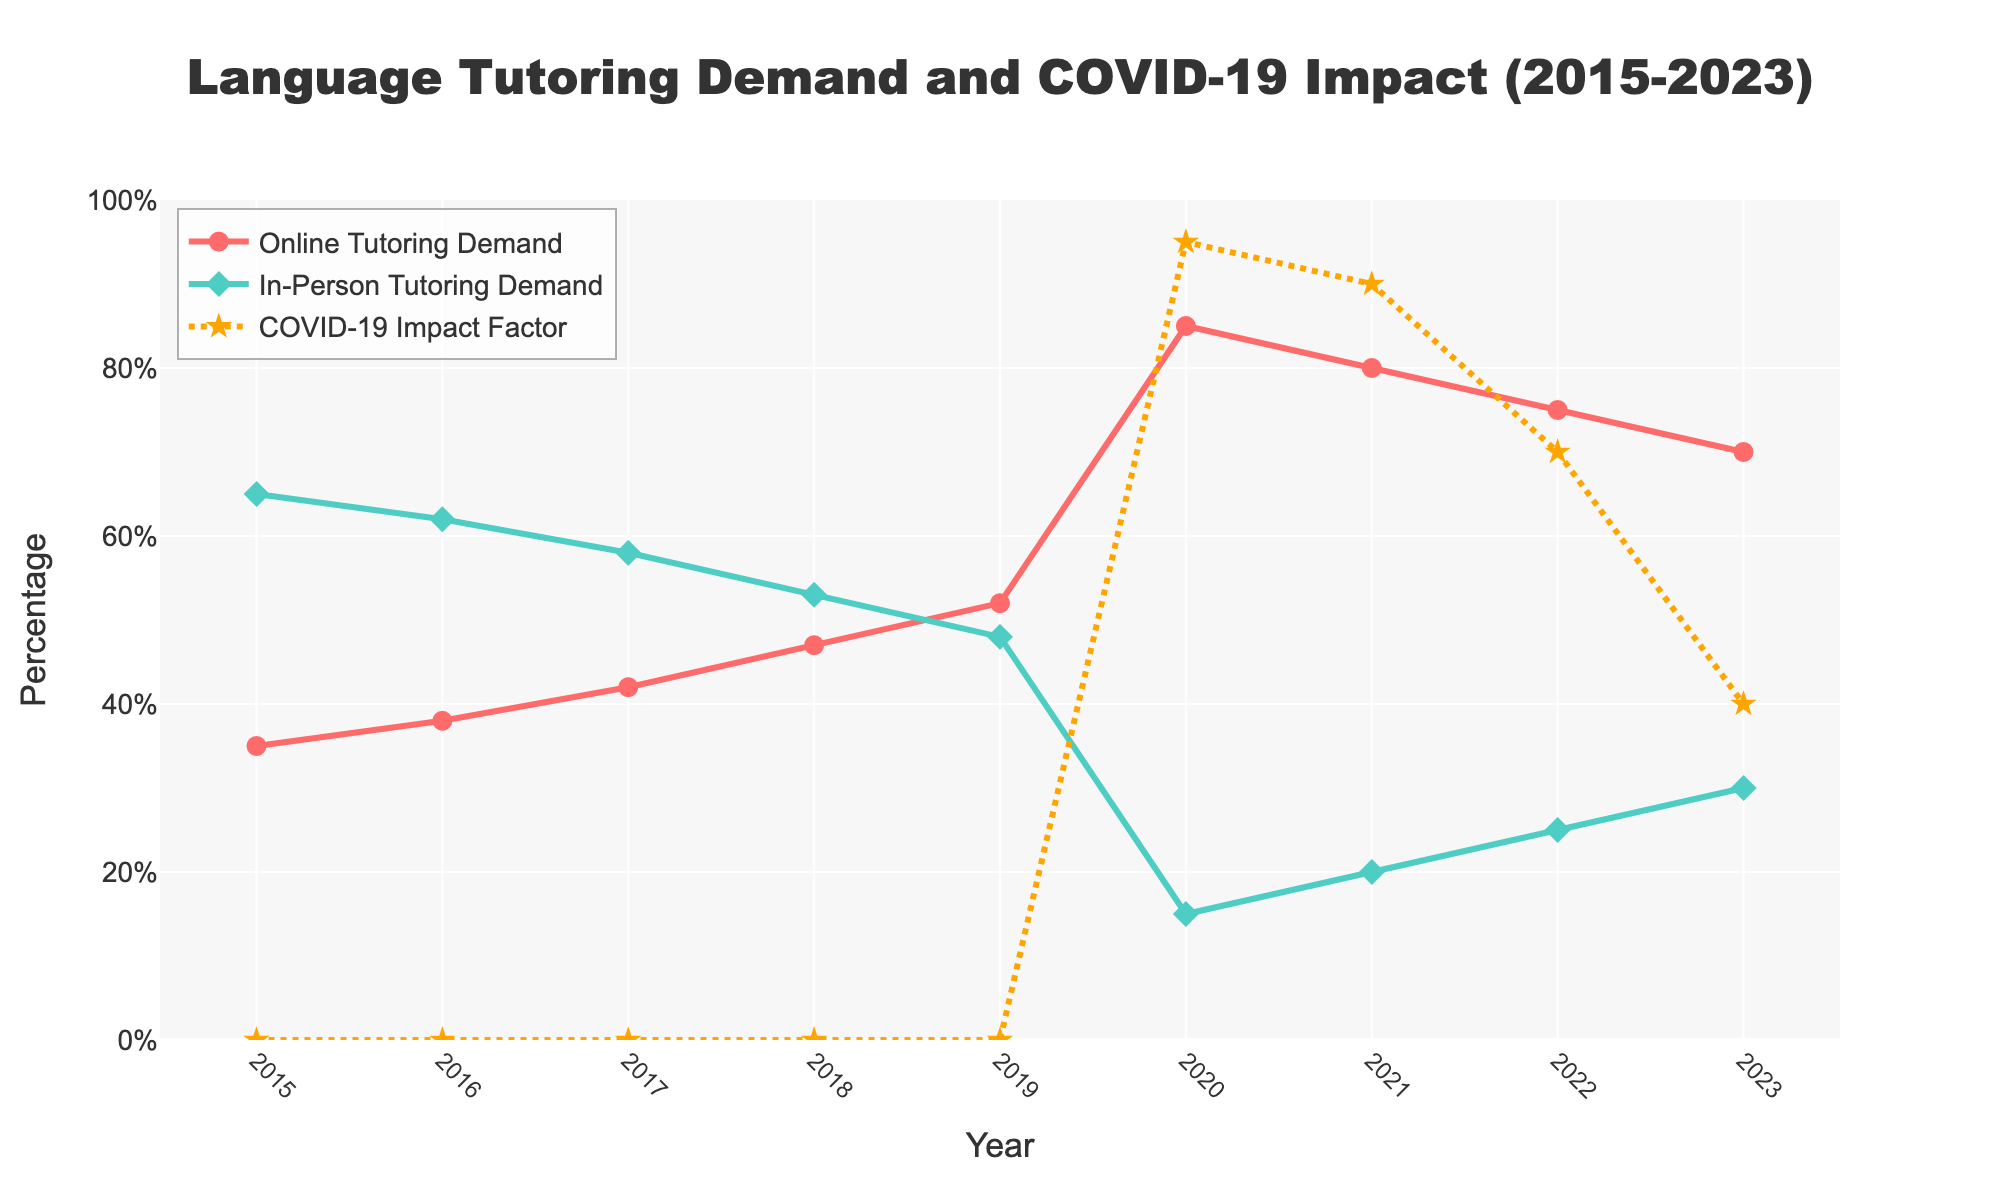Which year shows the highest demand for online tutoring? To find the year with the highest demand for online tutoring, look for the peak in the red line representing 'Online Tutoring Demand'. The highest point on this line is in the year 2020.
Answer: 2020 What is the difference in in-person tutoring demand between 2020 and 2023? Find the values for 'In-Person Tutoring Demand' in 2020 (15) and 2023 (30). Then, calculate the difference: 30 - 15 = 15.
Answer: 15 Which year experienced the highest impact from COVID-19? Look for the highest point on the orange line representing 'COVID-19 Impact Factor'. The peak occurs in the year 2020.
Answer: 2020 In which year did online tutoring demand surpass in-person tutoring demand for the first time? Compare the positions of the red ('Online Tutoring Demand') and green ('In-Person Tutoring Demand') lines. The red line is above the green line starting from 2019.
Answer: 2019 What is the average demand for online tutoring from 2015 to 2023? Sum the values of 'Online Tutoring Demand' from 2015 to 2023: 35 + 38 + 42 + 47 + 52 + 85 + 80 + 75 + 70 = 524. Then, divide by the number of years (9): 524 / 9 ≈ 58.22.
Answer: 58.22 By how much did the COVID-19 impact factor decrease between 2020 and 2023? Find the values for 'COVID-19 Impact Factor' in 2020 (95) and 2023 (40). Calculate the decrease: 95 - 40 = 55.
Answer: 55 What was the trend in in-person tutoring demand from 2015 to 2019? To determine the trend, look at the green line from 2015 (65) to 2019 (48). The line is consistently descending, indicating a decreasing trend.
Answer: Decreasing Which year had a higher demand for in-person tutoring: 2016 or 2022? Locate the 'In-Person Tutoring Demand' values for 2016 (62) and 2022 (25). Since 62 is greater than 25, the year 2016 had a higher demand.
Answer: 2016 How did the demand for online tutoring change between 2019 and 2020? Observe the 'Online Tutoring Demand' values for 2019 (52) and 2020 (85). There is a significant increase from 52 to 85.
Answer: Increased What is the average COVID-19 impact factor from 2020 to 2023? Sum the values of 'COVID-19 Impact Factor' from 2020 to 2023: 95 + 90 + 70 + 40 = 295. Then, divide by the number of years (4): 295 / 4 = 73.75.
Answer: 73.75 